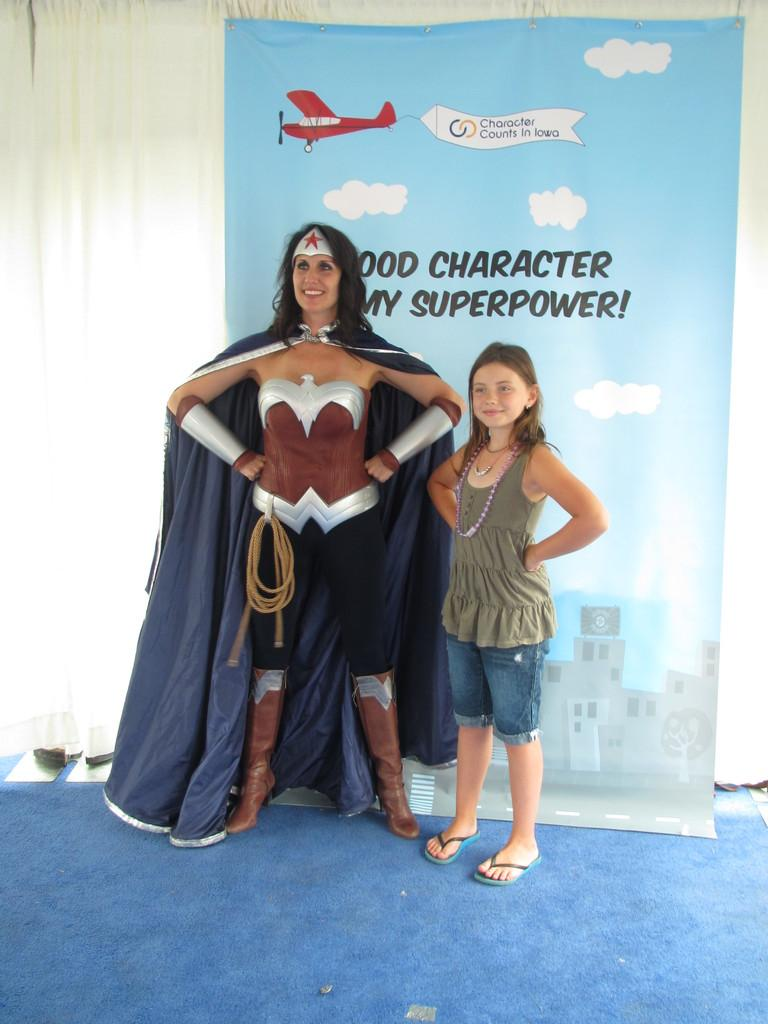<image>
Describe the image concisely. girl standing next to woman in wonder woman costume in front of background that states good character my superpower and a plane towing sign that says character counts in iowa 